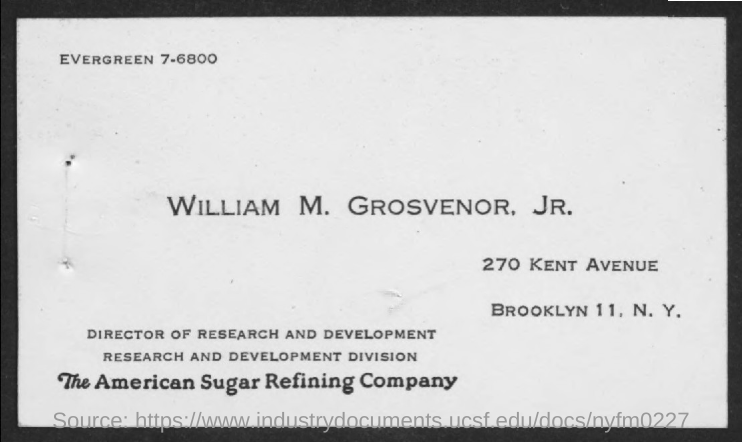Outline some significant characteristics in this image. William M. Grosvenor, Jr. is the Director of Research and Development. 